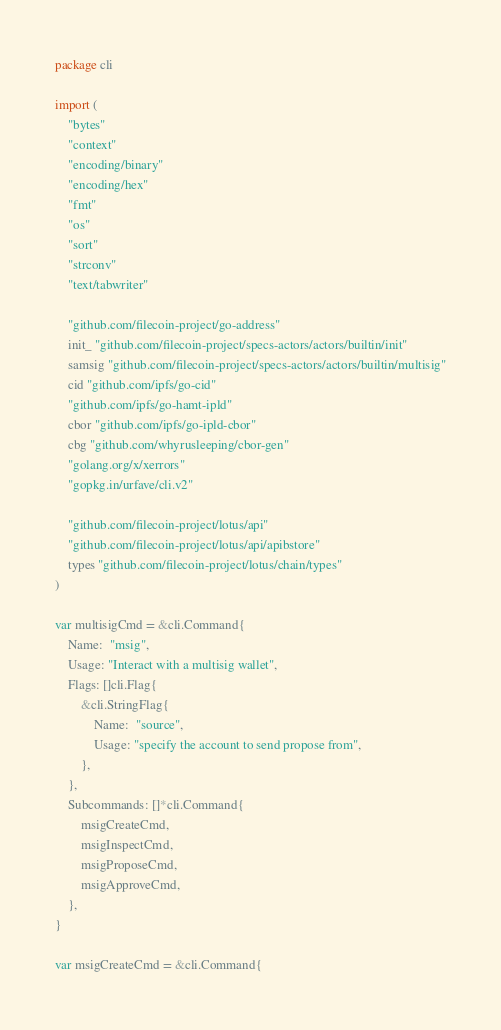Convert code to text. <code><loc_0><loc_0><loc_500><loc_500><_Go_>package cli

import (
	"bytes"
	"context"
	"encoding/binary"
	"encoding/hex"
	"fmt"
	"os"
	"sort"
	"strconv"
	"text/tabwriter"

	"github.com/filecoin-project/go-address"
	init_ "github.com/filecoin-project/specs-actors/actors/builtin/init"
	samsig "github.com/filecoin-project/specs-actors/actors/builtin/multisig"
	cid "github.com/ipfs/go-cid"
	"github.com/ipfs/go-hamt-ipld"
	cbor "github.com/ipfs/go-ipld-cbor"
	cbg "github.com/whyrusleeping/cbor-gen"
	"golang.org/x/xerrors"
	"gopkg.in/urfave/cli.v2"

	"github.com/filecoin-project/lotus/api"
	"github.com/filecoin-project/lotus/api/apibstore"
	types "github.com/filecoin-project/lotus/chain/types"
)

var multisigCmd = &cli.Command{
	Name:  "msig",
	Usage: "Interact with a multisig wallet",
	Flags: []cli.Flag{
		&cli.StringFlag{
			Name:  "source",
			Usage: "specify the account to send propose from",
		},
	},
	Subcommands: []*cli.Command{
		msigCreateCmd,
		msigInspectCmd,
		msigProposeCmd,
		msigApproveCmd,
	},
}

var msigCreateCmd = &cli.Command{</code> 